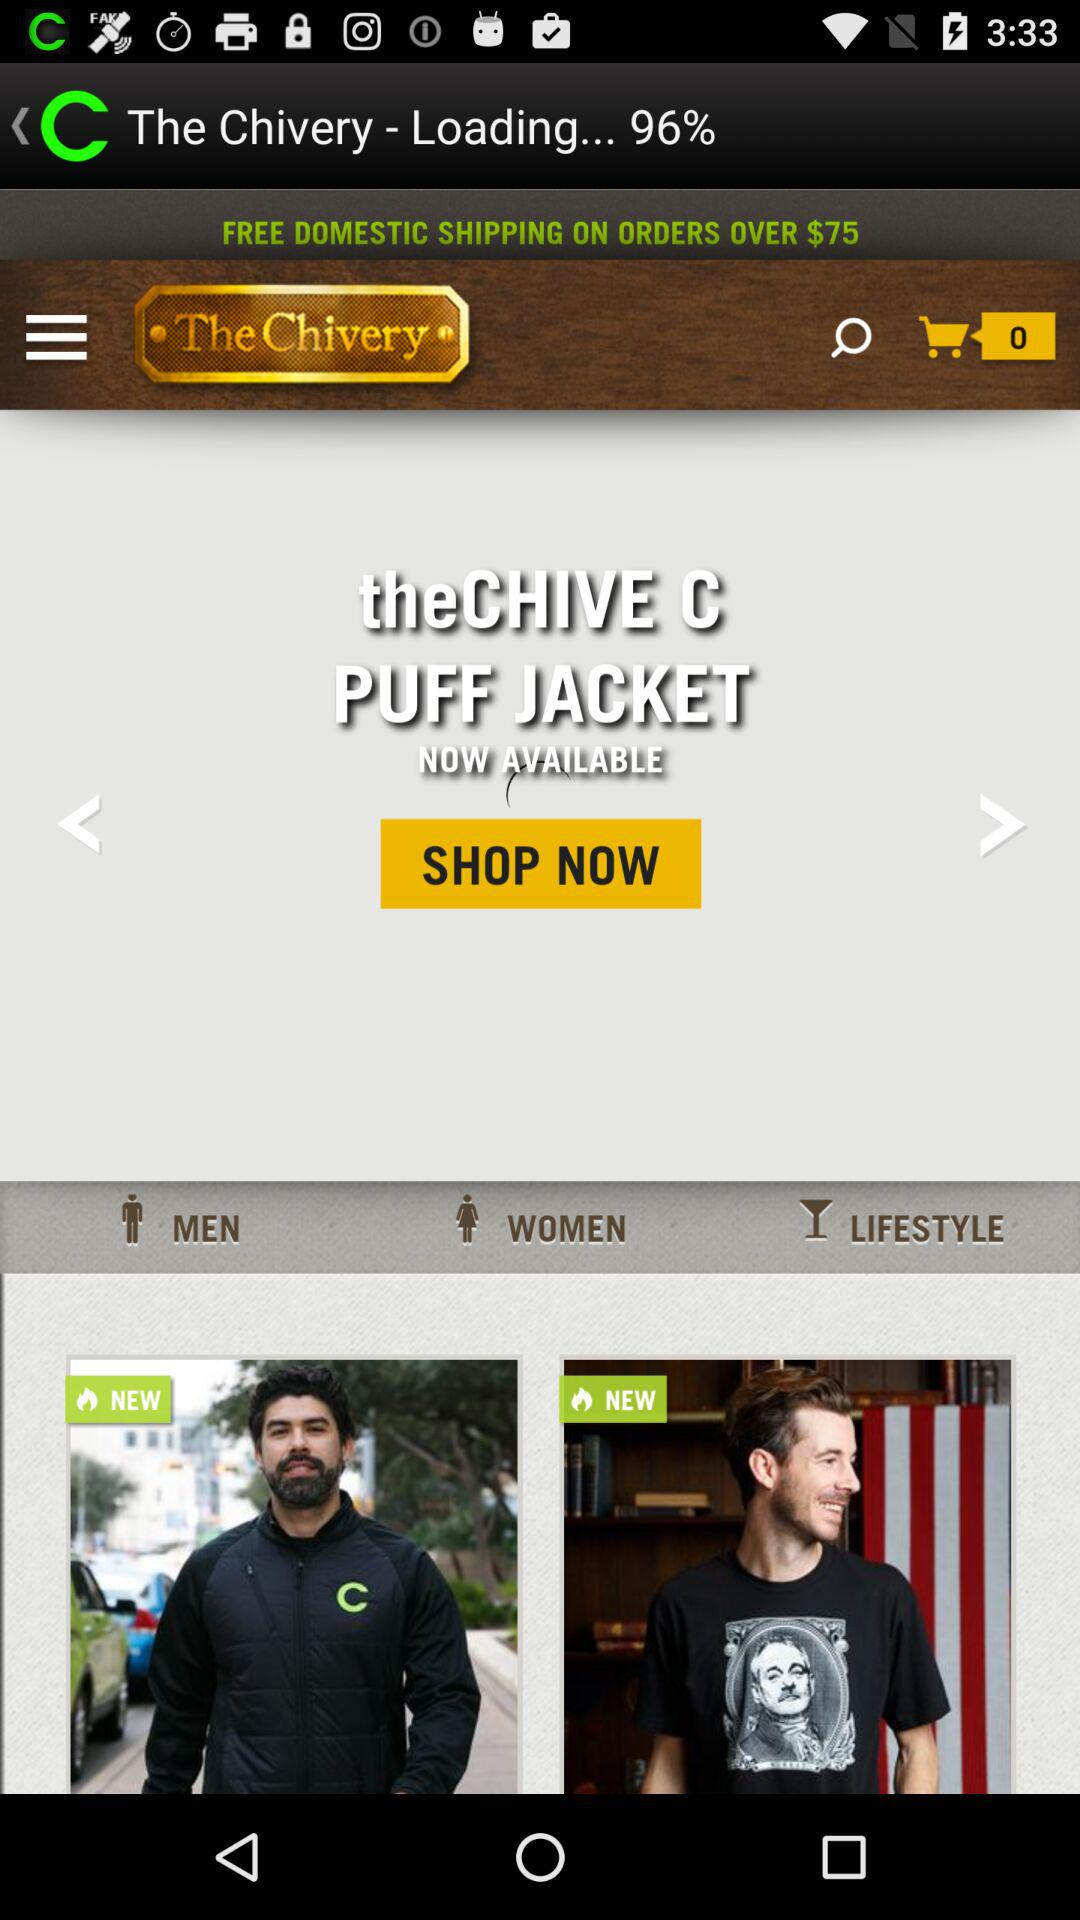What is the cost limit for "Free Domestic Shipping"? The cost limit is $75. 